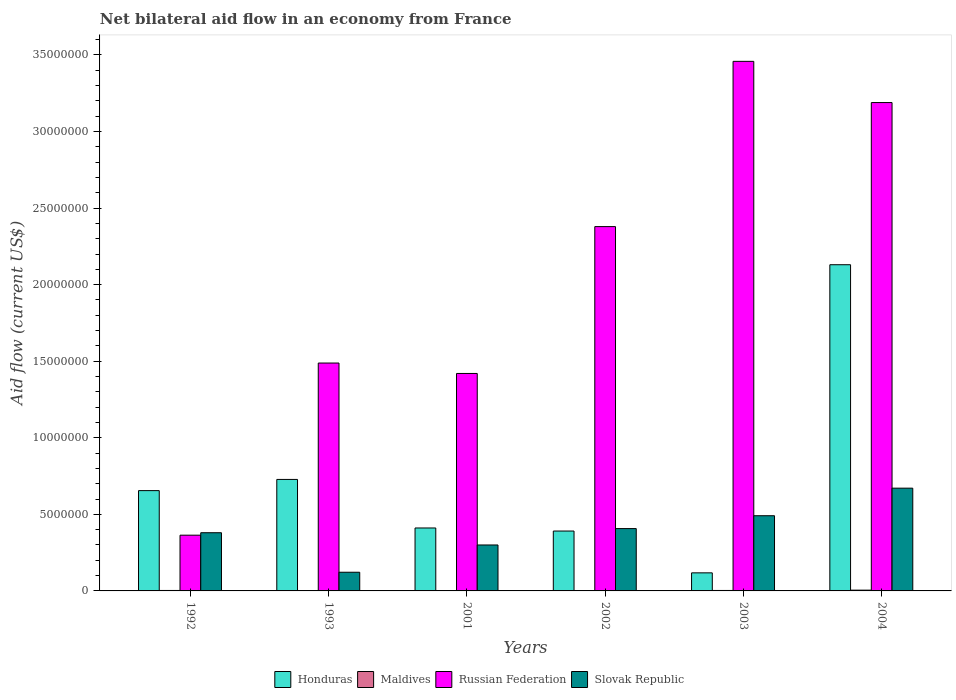How many bars are there on the 2nd tick from the left?
Provide a succinct answer. 4. In how many cases, is the number of bars for a given year not equal to the number of legend labels?
Your answer should be compact. 0. What is the net bilateral aid flow in Russian Federation in 2004?
Your answer should be compact. 3.19e+07. Across all years, what is the maximum net bilateral aid flow in Honduras?
Provide a succinct answer. 2.13e+07. Across all years, what is the minimum net bilateral aid flow in Slovak Republic?
Keep it short and to the point. 1.22e+06. In which year was the net bilateral aid flow in Maldives minimum?
Make the answer very short. 1993. What is the total net bilateral aid flow in Russian Federation in the graph?
Make the answer very short. 1.23e+08. What is the difference between the net bilateral aid flow in Russian Federation in 1993 and that in 2002?
Offer a terse response. -8.91e+06. What is the difference between the net bilateral aid flow in Slovak Republic in 1992 and the net bilateral aid flow in Honduras in 2004?
Your response must be concise. -1.75e+07. What is the average net bilateral aid flow in Slovak Republic per year?
Provide a short and direct response. 3.95e+06. In the year 2004, what is the difference between the net bilateral aid flow in Russian Federation and net bilateral aid flow in Honduras?
Provide a short and direct response. 1.06e+07. What is the ratio of the net bilateral aid flow in Slovak Republic in 2001 to that in 2003?
Provide a short and direct response. 0.61. Is the net bilateral aid flow in Maldives in 2001 less than that in 2004?
Your answer should be compact. Yes. What is the difference between the highest and the second highest net bilateral aid flow in Maldives?
Your answer should be compact. 2.00e+04. What is the difference between the highest and the lowest net bilateral aid flow in Honduras?
Your answer should be very brief. 2.01e+07. Is the sum of the net bilateral aid flow in Honduras in 1993 and 2002 greater than the maximum net bilateral aid flow in Maldives across all years?
Your answer should be compact. Yes. What does the 1st bar from the left in 2004 represents?
Keep it short and to the point. Honduras. What does the 1st bar from the right in 1992 represents?
Offer a terse response. Slovak Republic. Is it the case that in every year, the sum of the net bilateral aid flow in Honduras and net bilateral aid flow in Russian Federation is greater than the net bilateral aid flow in Maldives?
Provide a short and direct response. Yes. How many bars are there?
Ensure brevity in your answer.  24. What is the difference between two consecutive major ticks on the Y-axis?
Your response must be concise. 5.00e+06. Are the values on the major ticks of Y-axis written in scientific E-notation?
Offer a terse response. No. Does the graph contain any zero values?
Offer a very short reply. No. Does the graph contain grids?
Keep it short and to the point. No. Where does the legend appear in the graph?
Your answer should be compact. Bottom center. How many legend labels are there?
Offer a very short reply. 4. What is the title of the graph?
Provide a succinct answer. Net bilateral aid flow in an economy from France. What is the Aid flow (current US$) in Honduras in 1992?
Offer a very short reply. 6.55e+06. What is the Aid flow (current US$) in Maldives in 1992?
Your answer should be compact. 3.00e+04. What is the Aid flow (current US$) in Russian Federation in 1992?
Give a very brief answer. 3.64e+06. What is the Aid flow (current US$) in Slovak Republic in 1992?
Ensure brevity in your answer.  3.80e+06. What is the Aid flow (current US$) of Honduras in 1993?
Ensure brevity in your answer.  7.28e+06. What is the Aid flow (current US$) of Russian Federation in 1993?
Offer a terse response. 1.49e+07. What is the Aid flow (current US$) of Slovak Republic in 1993?
Offer a terse response. 1.22e+06. What is the Aid flow (current US$) in Honduras in 2001?
Offer a very short reply. 4.11e+06. What is the Aid flow (current US$) of Russian Federation in 2001?
Offer a very short reply. 1.42e+07. What is the Aid flow (current US$) in Honduras in 2002?
Your answer should be very brief. 3.91e+06. What is the Aid flow (current US$) of Maldives in 2002?
Keep it short and to the point. 2.00e+04. What is the Aid flow (current US$) of Russian Federation in 2002?
Your response must be concise. 2.38e+07. What is the Aid flow (current US$) of Slovak Republic in 2002?
Offer a very short reply. 4.07e+06. What is the Aid flow (current US$) of Honduras in 2003?
Make the answer very short. 1.18e+06. What is the Aid flow (current US$) in Russian Federation in 2003?
Offer a terse response. 3.46e+07. What is the Aid flow (current US$) in Slovak Republic in 2003?
Provide a succinct answer. 4.91e+06. What is the Aid flow (current US$) of Honduras in 2004?
Your answer should be very brief. 2.13e+07. What is the Aid flow (current US$) of Maldives in 2004?
Provide a succinct answer. 5.00e+04. What is the Aid flow (current US$) of Russian Federation in 2004?
Offer a terse response. 3.19e+07. What is the Aid flow (current US$) of Slovak Republic in 2004?
Provide a short and direct response. 6.71e+06. Across all years, what is the maximum Aid flow (current US$) in Honduras?
Offer a very short reply. 2.13e+07. Across all years, what is the maximum Aid flow (current US$) in Russian Federation?
Make the answer very short. 3.46e+07. Across all years, what is the maximum Aid flow (current US$) of Slovak Republic?
Keep it short and to the point. 6.71e+06. Across all years, what is the minimum Aid flow (current US$) in Honduras?
Make the answer very short. 1.18e+06. Across all years, what is the minimum Aid flow (current US$) of Russian Federation?
Your response must be concise. 3.64e+06. Across all years, what is the minimum Aid flow (current US$) in Slovak Republic?
Your answer should be compact. 1.22e+06. What is the total Aid flow (current US$) in Honduras in the graph?
Your answer should be very brief. 4.43e+07. What is the total Aid flow (current US$) in Maldives in the graph?
Provide a succinct answer. 1.60e+05. What is the total Aid flow (current US$) of Russian Federation in the graph?
Your answer should be compact. 1.23e+08. What is the total Aid flow (current US$) in Slovak Republic in the graph?
Provide a short and direct response. 2.37e+07. What is the difference between the Aid flow (current US$) in Honduras in 1992 and that in 1993?
Ensure brevity in your answer.  -7.30e+05. What is the difference between the Aid flow (current US$) of Maldives in 1992 and that in 1993?
Offer a very short reply. 2.00e+04. What is the difference between the Aid flow (current US$) of Russian Federation in 1992 and that in 1993?
Provide a short and direct response. -1.12e+07. What is the difference between the Aid flow (current US$) of Slovak Republic in 1992 and that in 1993?
Give a very brief answer. 2.58e+06. What is the difference between the Aid flow (current US$) in Honduras in 1992 and that in 2001?
Provide a succinct answer. 2.44e+06. What is the difference between the Aid flow (current US$) of Maldives in 1992 and that in 2001?
Make the answer very short. 10000. What is the difference between the Aid flow (current US$) in Russian Federation in 1992 and that in 2001?
Make the answer very short. -1.06e+07. What is the difference between the Aid flow (current US$) of Honduras in 1992 and that in 2002?
Your answer should be very brief. 2.64e+06. What is the difference between the Aid flow (current US$) in Russian Federation in 1992 and that in 2002?
Your answer should be very brief. -2.02e+07. What is the difference between the Aid flow (current US$) in Slovak Republic in 1992 and that in 2002?
Your answer should be compact. -2.70e+05. What is the difference between the Aid flow (current US$) in Honduras in 1992 and that in 2003?
Your response must be concise. 5.37e+06. What is the difference between the Aid flow (current US$) in Russian Federation in 1992 and that in 2003?
Ensure brevity in your answer.  -3.09e+07. What is the difference between the Aid flow (current US$) in Slovak Republic in 1992 and that in 2003?
Offer a very short reply. -1.11e+06. What is the difference between the Aid flow (current US$) of Honduras in 1992 and that in 2004?
Your answer should be very brief. -1.48e+07. What is the difference between the Aid flow (current US$) in Maldives in 1992 and that in 2004?
Keep it short and to the point. -2.00e+04. What is the difference between the Aid flow (current US$) in Russian Federation in 1992 and that in 2004?
Keep it short and to the point. -2.82e+07. What is the difference between the Aid flow (current US$) of Slovak Republic in 1992 and that in 2004?
Your answer should be very brief. -2.91e+06. What is the difference between the Aid flow (current US$) in Honduras in 1993 and that in 2001?
Provide a succinct answer. 3.17e+06. What is the difference between the Aid flow (current US$) of Russian Federation in 1993 and that in 2001?
Provide a succinct answer. 6.80e+05. What is the difference between the Aid flow (current US$) in Slovak Republic in 1993 and that in 2001?
Keep it short and to the point. -1.78e+06. What is the difference between the Aid flow (current US$) of Honduras in 1993 and that in 2002?
Your answer should be very brief. 3.37e+06. What is the difference between the Aid flow (current US$) in Maldives in 1993 and that in 2002?
Give a very brief answer. -10000. What is the difference between the Aid flow (current US$) of Russian Federation in 1993 and that in 2002?
Your response must be concise. -8.91e+06. What is the difference between the Aid flow (current US$) in Slovak Republic in 1993 and that in 2002?
Provide a short and direct response. -2.85e+06. What is the difference between the Aid flow (current US$) of Honduras in 1993 and that in 2003?
Your answer should be very brief. 6.10e+06. What is the difference between the Aid flow (current US$) of Russian Federation in 1993 and that in 2003?
Provide a succinct answer. -1.97e+07. What is the difference between the Aid flow (current US$) in Slovak Republic in 1993 and that in 2003?
Give a very brief answer. -3.69e+06. What is the difference between the Aid flow (current US$) in Honduras in 1993 and that in 2004?
Ensure brevity in your answer.  -1.40e+07. What is the difference between the Aid flow (current US$) in Maldives in 1993 and that in 2004?
Your answer should be very brief. -4.00e+04. What is the difference between the Aid flow (current US$) in Russian Federation in 1993 and that in 2004?
Provide a short and direct response. -1.70e+07. What is the difference between the Aid flow (current US$) of Slovak Republic in 1993 and that in 2004?
Provide a succinct answer. -5.49e+06. What is the difference between the Aid flow (current US$) in Maldives in 2001 and that in 2002?
Your answer should be compact. 0. What is the difference between the Aid flow (current US$) in Russian Federation in 2001 and that in 2002?
Provide a short and direct response. -9.59e+06. What is the difference between the Aid flow (current US$) in Slovak Republic in 2001 and that in 2002?
Your answer should be very brief. -1.07e+06. What is the difference between the Aid flow (current US$) of Honduras in 2001 and that in 2003?
Make the answer very short. 2.93e+06. What is the difference between the Aid flow (current US$) of Maldives in 2001 and that in 2003?
Your response must be concise. -10000. What is the difference between the Aid flow (current US$) in Russian Federation in 2001 and that in 2003?
Give a very brief answer. -2.04e+07. What is the difference between the Aid flow (current US$) in Slovak Republic in 2001 and that in 2003?
Your answer should be very brief. -1.91e+06. What is the difference between the Aid flow (current US$) of Honduras in 2001 and that in 2004?
Provide a succinct answer. -1.72e+07. What is the difference between the Aid flow (current US$) of Maldives in 2001 and that in 2004?
Keep it short and to the point. -3.00e+04. What is the difference between the Aid flow (current US$) in Russian Federation in 2001 and that in 2004?
Your answer should be very brief. -1.77e+07. What is the difference between the Aid flow (current US$) in Slovak Republic in 2001 and that in 2004?
Offer a terse response. -3.71e+06. What is the difference between the Aid flow (current US$) in Honduras in 2002 and that in 2003?
Provide a short and direct response. 2.73e+06. What is the difference between the Aid flow (current US$) in Russian Federation in 2002 and that in 2003?
Offer a very short reply. -1.08e+07. What is the difference between the Aid flow (current US$) in Slovak Republic in 2002 and that in 2003?
Your answer should be compact. -8.40e+05. What is the difference between the Aid flow (current US$) of Honduras in 2002 and that in 2004?
Your answer should be very brief. -1.74e+07. What is the difference between the Aid flow (current US$) in Maldives in 2002 and that in 2004?
Ensure brevity in your answer.  -3.00e+04. What is the difference between the Aid flow (current US$) of Russian Federation in 2002 and that in 2004?
Your response must be concise. -8.10e+06. What is the difference between the Aid flow (current US$) of Slovak Republic in 2002 and that in 2004?
Offer a terse response. -2.64e+06. What is the difference between the Aid flow (current US$) in Honduras in 2003 and that in 2004?
Give a very brief answer. -2.01e+07. What is the difference between the Aid flow (current US$) in Maldives in 2003 and that in 2004?
Make the answer very short. -2.00e+04. What is the difference between the Aid flow (current US$) in Russian Federation in 2003 and that in 2004?
Your answer should be compact. 2.69e+06. What is the difference between the Aid flow (current US$) of Slovak Republic in 2003 and that in 2004?
Your answer should be compact. -1.80e+06. What is the difference between the Aid flow (current US$) of Honduras in 1992 and the Aid flow (current US$) of Maldives in 1993?
Keep it short and to the point. 6.54e+06. What is the difference between the Aid flow (current US$) in Honduras in 1992 and the Aid flow (current US$) in Russian Federation in 1993?
Ensure brevity in your answer.  -8.33e+06. What is the difference between the Aid flow (current US$) of Honduras in 1992 and the Aid flow (current US$) of Slovak Republic in 1993?
Provide a succinct answer. 5.33e+06. What is the difference between the Aid flow (current US$) of Maldives in 1992 and the Aid flow (current US$) of Russian Federation in 1993?
Ensure brevity in your answer.  -1.48e+07. What is the difference between the Aid flow (current US$) of Maldives in 1992 and the Aid flow (current US$) of Slovak Republic in 1993?
Your response must be concise. -1.19e+06. What is the difference between the Aid flow (current US$) of Russian Federation in 1992 and the Aid flow (current US$) of Slovak Republic in 1993?
Make the answer very short. 2.42e+06. What is the difference between the Aid flow (current US$) of Honduras in 1992 and the Aid flow (current US$) of Maldives in 2001?
Make the answer very short. 6.53e+06. What is the difference between the Aid flow (current US$) in Honduras in 1992 and the Aid flow (current US$) in Russian Federation in 2001?
Your response must be concise. -7.65e+06. What is the difference between the Aid flow (current US$) in Honduras in 1992 and the Aid flow (current US$) in Slovak Republic in 2001?
Keep it short and to the point. 3.55e+06. What is the difference between the Aid flow (current US$) in Maldives in 1992 and the Aid flow (current US$) in Russian Federation in 2001?
Keep it short and to the point. -1.42e+07. What is the difference between the Aid flow (current US$) in Maldives in 1992 and the Aid flow (current US$) in Slovak Republic in 2001?
Keep it short and to the point. -2.97e+06. What is the difference between the Aid flow (current US$) of Russian Federation in 1992 and the Aid flow (current US$) of Slovak Republic in 2001?
Offer a very short reply. 6.40e+05. What is the difference between the Aid flow (current US$) of Honduras in 1992 and the Aid flow (current US$) of Maldives in 2002?
Your answer should be compact. 6.53e+06. What is the difference between the Aid flow (current US$) in Honduras in 1992 and the Aid flow (current US$) in Russian Federation in 2002?
Ensure brevity in your answer.  -1.72e+07. What is the difference between the Aid flow (current US$) of Honduras in 1992 and the Aid flow (current US$) of Slovak Republic in 2002?
Give a very brief answer. 2.48e+06. What is the difference between the Aid flow (current US$) of Maldives in 1992 and the Aid flow (current US$) of Russian Federation in 2002?
Ensure brevity in your answer.  -2.38e+07. What is the difference between the Aid flow (current US$) of Maldives in 1992 and the Aid flow (current US$) of Slovak Republic in 2002?
Ensure brevity in your answer.  -4.04e+06. What is the difference between the Aid flow (current US$) of Russian Federation in 1992 and the Aid flow (current US$) of Slovak Republic in 2002?
Offer a very short reply. -4.30e+05. What is the difference between the Aid flow (current US$) in Honduras in 1992 and the Aid flow (current US$) in Maldives in 2003?
Your answer should be compact. 6.52e+06. What is the difference between the Aid flow (current US$) in Honduras in 1992 and the Aid flow (current US$) in Russian Federation in 2003?
Your answer should be very brief. -2.80e+07. What is the difference between the Aid flow (current US$) of Honduras in 1992 and the Aid flow (current US$) of Slovak Republic in 2003?
Offer a very short reply. 1.64e+06. What is the difference between the Aid flow (current US$) in Maldives in 1992 and the Aid flow (current US$) in Russian Federation in 2003?
Ensure brevity in your answer.  -3.46e+07. What is the difference between the Aid flow (current US$) in Maldives in 1992 and the Aid flow (current US$) in Slovak Republic in 2003?
Offer a terse response. -4.88e+06. What is the difference between the Aid flow (current US$) of Russian Federation in 1992 and the Aid flow (current US$) of Slovak Republic in 2003?
Your answer should be very brief. -1.27e+06. What is the difference between the Aid flow (current US$) in Honduras in 1992 and the Aid flow (current US$) in Maldives in 2004?
Offer a terse response. 6.50e+06. What is the difference between the Aid flow (current US$) of Honduras in 1992 and the Aid flow (current US$) of Russian Federation in 2004?
Offer a very short reply. -2.53e+07. What is the difference between the Aid flow (current US$) in Honduras in 1992 and the Aid flow (current US$) in Slovak Republic in 2004?
Offer a terse response. -1.60e+05. What is the difference between the Aid flow (current US$) of Maldives in 1992 and the Aid flow (current US$) of Russian Federation in 2004?
Your answer should be very brief. -3.19e+07. What is the difference between the Aid flow (current US$) in Maldives in 1992 and the Aid flow (current US$) in Slovak Republic in 2004?
Your answer should be very brief. -6.68e+06. What is the difference between the Aid flow (current US$) of Russian Federation in 1992 and the Aid flow (current US$) of Slovak Republic in 2004?
Provide a succinct answer. -3.07e+06. What is the difference between the Aid flow (current US$) in Honduras in 1993 and the Aid flow (current US$) in Maldives in 2001?
Give a very brief answer. 7.26e+06. What is the difference between the Aid flow (current US$) of Honduras in 1993 and the Aid flow (current US$) of Russian Federation in 2001?
Your answer should be very brief. -6.92e+06. What is the difference between the Aid flow (current US$) of Honduras in 1993 and the Aid flow (current US$) of Slovak Republic in 2001?
Your answer should be compact. 4.28e+06. What is the difference between the Aid flow (current US$) of Maldives in 1993 and the Aid flow (current US$) of Russian Federation in 2001?
Give a very brief answer. -1.42e+07. What is the difference between the Aid flow (current US$) in Maldives in 1993 and the Aid flow (current US$) in Slovak Republic in 2001?
Your response must be concise. -2.99e+06. What is the difference between the Aid flow (current US$) in Russian Federation in 1993 and the Aid flow (current US$) in Slovak Republic in 2001?
Make the answer very short. 1.19e+07. What is the difference between the Aid flow (current US$) of Honduras in 1993 and the Aid flow (current US$) of Maldives in 2002?
Your answer should be compact. 7.26e+06. What is the difference between the Aid flow (current US$) of Honduras in 1993 and the Aid flow (current US$) of Russian Federation in 2002?
Your response must be concise. -1.65e+07. What is the difference between the Aid flow (current US$) of Honduras in 1993 and the Aid flow (current US$) of Slovak Republic in 2002?
Your answer should be very brief. 3.21e+06. What is the difference between the Aid flow (current US$) of Maldives in 1993 and the Aid flow (current US$) of Russian Federation in 2002?
Offer a terse response. -2.38e+07. What is the difference between the Aid flow (current US$) of Maldives in 1993 and the Aid flow (current US$) of Slovak Republic in 2002?
Offer a very short reply. -4.06e+06. What is the difference between the Aid flow (current US$) in Russian Federation in 1993 and the Aid flow (current US$) in Slovak Republic in 2002?
Your response must be concise. 1.08e+07. What is the difference between the Aid flow (current US$) in Honduras in 1993 and the Aid flow (current US$) in Maldives in 2003?
Your answer should be very brief. 7.25e+06. What is the difference between the Aid flow (current US$) of Honduras in 1993 and the Aid flow (current US$) of Russian Federation in 2003?
Provide a short and direct response. -2.73e+07. What is the difference between the Aid flow (current US$) of Honduras in 1993 and the Aid flow (current US$) of Slovak Republic in 2003?
Offer a terse response. 2.37e+06. What is the difference between the Aid flow (current US$) of Maldives in 1993 and the Aid flow (current US$) of Russian Federation in 2003?
Give a very brief answer. -3.46e+07. What is the difference between the Aid flow (current US$) of Maldives in 1993 and the Aid flow (current US$) of Slovak Republic in 2003?
Provide a succinct answer. -4.90e+06. What is the difference between the Aid flow (current US$) in Russian Federation in 1993 and the Aid flow (current US$) in Slovak Republic in 2003?
Offer a terse response. 9.97e+06. What is the difference between the Aid flow (current US$) in Honduras in 1993 and the Aid flow (current US$) in Maldives in 2004?
Ensure brevity in your answer.  7.23e+06. What is the difference between the Aid flow (current US$) in Honduras in 1993 and the Aid flow (current US$) in Russian Federation in 2004?
Offer a very short reply. -2.46e+07. What is the difference between the Aid flow (current US$) of Honduras in 1993 and the Aid flow (current US$) of Slovak Republic in 2004?
Your answer should be compact. 5.70e+05. What is the difference between the Aid flow (current US$) in Maldives in 1993 and the Aid flow (current US$) in Russian Federation in 2004?
Give a very brief answer. -3.19e+07. What is the difference between the Aid flow (current US$) of Maldives in 1993 and the Aid flow (current US$) of Slovak Republic in 2004?
Offer a terse response. -6.70e+06. What is the difference between the Aid flow (current US$) in Russian Federation in 1993 and the Aid flow (current US$) in Slovak Republic in 2004?
Make the answer very short. 8.17e+06. What is the difference between the Aid flow (current US$) in Honduras in 2001 and the Aid flow (current US$) in Maldives in 2002?
Your answer should be very brief. 4.09e+06. What is the difference between the Aid flow (current US$) in Honduras in 2001 and the Aid flow (current US$) in Russian Federation in 2002?
Your response must be concise. -1.97e+07. What is the difference between the Aid flow (current US$) in Maldives in 2001 and the Aid flow (current US$) in Russian Federation in 2002?
Your response must be concise. -2.38e+07. What is the difference between the Aid flow (current US$) in Maldives in 2001 and the Aid flow (current US$) in Slovak Republic in 2002?
Make the answer very short. -4.05e+06. What is the difference between the Aid flow (current US$) in Russian Federation in 2001 and the Aid flow (current US$) in Slovak Republic in 2002?
Make the answer very short. 1.01e+07. What is the difference between the Aid flow (current US$) in Honduras in 2001 and the Aid flow (current US$) in Maldives in 2003?
Provide a short and direct response. 4.08e+06. What is the difference between the Aid flow (current US$) of Honduras in 2001 and the Aid flow (current US$) of Russian Federation in 2003?
Provide a short and direct response. -3.05e+07. What is the difference between the Aid flow (current US$) of Honduras in 2001 and the Aid flow (current US$) of Slovak Republic in 2003?
Offer a terse response. -8.00e+05. What is the difference between the Aid flow (current US$) of Maldives in 2001 and the Aid flow (current US$) of Russian Federation in 2003?
Make the answer very short. -3.46e+07. What is the difference between the Aid flow (current US$) of Maldives in 2001 and the Aid flow (current US$) of Slovak Republic in 2003?
Ensure brevity in your answer.  -4.89e+06. What is the difference between the Aid flow (current US$) of Russian Federation in 2001 and the Aid flow (current US$) of Slovak Republic in 2003?
Give a very brief answer. 9.29e+06. What is the difference between the Aid flow (current US$) in Honduras in 2001 and the Aid flow (current US$) in Maldives in 2004?
Offer a very short reply. 4.06e+06. What is the difference between the Aid flow (current US$) of Honduras in 2001 and the Aid flow (current US$) of Russian Federation in 2004?
Provide a succinct answer. -2.78e+07. What is the difference between the Aid flow (current US$) of Honduras in 2001 and the Aid flow (current US$) of Slovak Republic in 2004?
Ensure brevity in your answer.  -2.60e+06. What is the difference between the Aid flow (current US$) of Maldives in 2001 and the Aid flow (current US$) of Russian Federation in 2004?
Keep it short and to the point. -3.19e+07. What is the difference between the Aid flow (current US$) of Maldives in 2001 and the Aid flow (current US$) of Slovak Republic in 2004?
Offer a very short reply. -6.69e+06. What is the difference between the Aid flow (current US$) in Russian Federation in 2001 and the Aid flow (current US$) in Slovak Republic in 2004?
Provide a short and direct response. 7.49e+06. What is the difference between the Aid flow (current US$) in Honduras in 2002 and the Aid flow (current US$) in Maldives in 2003?
Offer a very short reply. 3.88e+06. What is the difference between the Aid flow (current US$) in Honduras in 2002 and the Aid flow (current US$) in Russian Federation in 2003?
Make the answer very short. -3.07e+07. What is the difference between the Aid flow (current US$) in Honduras in 2002 and the Aid flow (current US$) in Slovak Republic in 2003?
Give a very brief answer. -1.00e+06. What is the difference between the Aid flow (current US$) of Maldives in 2002 and the Aid flow (current US$) of Russian Federation in 2003?
Ensure brevity in your answer.  -3.46e+07. What is the difference between the Aid flow (current US$) in Maldives in 2002 and the Aid flow (current US$) in Slovak Republic in 2003?
Provide a succinct answer. -4.89e+06. What is the difference between the Aid flow (current US$) in Russian Federation in 2002 and the Aid flow (current US$) in Slovak Republic in 2003?
Your answer should be compact. 1.89e+07. What is the difference between the Aid flow (current US$) of Honduras in 2002 and the Aid flow (current US$) of Maldives in 2004?
Keep it short and to the point. 3.86e+06. What is the difference between the Aid flow (current US$) in Honduras in 2002 and the Aid flow (current US$) in Russian Federation in 2004?
Your answer should be compact. -2.80e+07. What is the difference between the Aid flow (current US$) in Honduras in 2002 and the Aid flow (current US$) in Slovak Republic in 2004?
Give a very brief answer. -2.80e+06. What is the difference between the Aid flow (current US$) in Maldives in 2002 and the Aid flow (current US$) in Russian Federation in 2004?
Give a very brief answer. -3.19e+07. What is the difference between the Aid flow (current US$) of Maldives in 2002 and the Aid flow (current US$) of Slovak Republic in 2004?
Your response must be concise. -6.69e+06. What is the difference between the Aid flow (current US$) in Russian Federation in 2002 and the Aid flow (current US$) in Slovak Republic in 2004?
Offer a terse response. 1.71e+07. What is the difference between the Aid flow (current US$) of Honduras in 2003 and the Aid flow (current US$) of Maldives in 2004?
Give a very brief answer. 1.13e+06. What is the difference between the Aid flow (current US$) in Honduras in 2003 and the Aid flow (current US$) in Russian Federation in 2004?
Ensure brevity in your answer.  -3.07e+07. What is the difference between the Aid flow (current US$) of Honduras in 2003 and the Aid flow (current US$) of Slovak Republic in 2004?
Your response must be concise. -5.53e+06. What is the difference between the Aid flow (current US$) in Maldives in 2003 and the Aid flow (current US$) in Russian Federation in 2004?
Keep it short and to the point. -3.19e+07. What is the difference between the Aid flow (current US$) of Maldives in 2003 and the Aid flow (current US$) of Slovak Republic in 2004?
Provide a succinct answer. -6.68e+06. What is the difference between the Aid flow (current US$) of Russian Federation in 2003 and the Aid flow (current US$) of Slovak Republic in 2004?
Provide a short and direct response. 2.79e+07. What is the average Aid flow (current US$) in Honduras per year?
Keep it short and to the point. 7.39e+06. What is the average Aid flow (current US$) in Maldives per year?
Provide a succinct answer. 2.67e+04. What is the average Aid flow (current US$) in Russian Federation per year?
Keep it short and to the point. 2.05e+07. What is the average Aid flow (current US$) of Slovak Republic per year?
Give a very brief answer. 3.95e+06. In the year 1992, what is the difference between the Aid flow (current US$) of Honduras and Aid flow (current US$) of Maldives?
Your answer should be very brief. 6.52e+06. In the year 1992, what is the difference between the Aid flow (current US$) of Honduras and Aid flow (current US$) of Russian Federation?
Ensure brevity in your answer.  2.91e+06. In the year 1992, what is the difference between the Aid flow (current US$) of Honduras and Aid flow (current US$) of Slovak Republic?
Keep it short and to the point. 2.75e+06. In the year 1992, what is the difference between the Aid flow (current US$) of Maldives and Aid flow (current US$) of Russian Federation?
Provide a short and direct response. -3.61e+06. In the year 1992, what is the difference between the Aid flow (current US$) in Maldives and Aid flow (current US$) in Slovak Republic?
Your answer should be very brief. -3.77e+06. In the year 1992, what is the difference between the Aid flow (current US$) in Russian Federation and Aid flow (current US$) in Slovak Republic?
Ensure brevity in your answer.  -1.60e+05. In the year 1993, what is the difference between the Aid flow (current US$) in Honduras and Aid flow (current US$) in Maldives?
Ensure brevity in your answer.  7.27e+06. In the year 1993, what is the difference between the Aid flow (current US$) in Honduras and Aid flow (current US$) in Russian Federation?
Your response must be concise. -7.60e+06. In the year 1993, what is the difference between the Aid flow (current US$) of Honduras and Aid flow (current US$) of Slovak Republic?
Ensure brevity in your answer.  6.06e+06. In the year 1993, what is the difference between the Aid flow (current US$) in Maldives and Aid flow (current US$) in Russian Federation?
Give a very brief answer. -1.49e+07. In the year 1993, what is the difference between the Aid flow (current US$) of Maldives and Aid flow (current US$) of Slovak Republic?
Keep it short and to the point. -1.21e+06. In the year 1993, what is the difference between the Aid flow (current US$) of Russian Federation and Aid flow (current US$) of Slovak Republic?
Ensure brevity in your answer.  1.37e+07. In the year 2001, what is the difference between the Aid flow (current US$) of Honduras and Aid flow (current US$) of Maldives?
Ensure brevity in your answer.  4.09e+06. In the year 2001, what is the difference between the Aid flow (current US$) in Honduras and Aid flow (current US$) in Russian Federation?
Make the answer very short. -1.01e+07. In the year 2001, what is the difference between the Aid flow (current US$) of Honduras and Aid flow (current US$) of Slovak Republic?
Make the answer very short. 1.11e+06. In the year 2001, what is the difference between the Aid flow (current US$) in Maldives and Aid flow (current US$) in Russian Federation?
Ensure brevity in your answer.  -1.42e+07. In the year 2001, what is the difference between the Aid flow (current US$) of Maldives and Aid flow (current US$) of Slovak Republic?
Give a very brief answer. -2.98e+06. In the year 2001, what is the difference between the Aid flow (current US$) in Russian Federation and Aid flow (current US$) in Slovak Republic?
Provide a short and direct response. 1.12e+07. In the year 2002, what is the difference between the Aid flow (current US$) in Honduras and Aid flow (current US$) in Maldives?
Ensure brevity in your answer.  3.89e+06. In the year 2002, what is the difference between the Aid flow (current US$) of Honduras and Aid flow (current US$) of Russian Federation?
Give a very brief answer. -1.99e+07. In the year 2002, what is the difference between the Aid flow (current US$) of Honduras and Aid flow (current US$) of Slovak Republic?
Give a very brief answer. -1.60e+05. In the year 2002, what is the difference between the Aid flow (current US$) in Maldives and Aid flow (current US$) in Russian Federation?
Your answer should be compact. -2.38e+07. In the year 2002, what is the difference between the Aid flow (current US$) of Maldives and Aid flow (current US$) of Slovak Republic?
Keep it short and to the point. -4.05e+06. In the year 2002, what is the difference between the Aid flow (current US$) of Russian Federation and Aid flow (current US$) of Slovak Republic?
Give a very brief answer. 1.97e+07. In the year 2003, what is the difference between the Aid flow (current US$) in Honduras and Aid flow (current US$) in Maldives?
Offer a terse response. 1.15e+06. In the year 2003, what is the difference between the Aid flow (current US$) in Honduras and Aid flow (current US$) in Russian Federation?
Your answer should be compact. -3.34e+07. In the year 2003, what is the difference between the Aid flow (current US$) of Honduras and Aid flow (current US$) of Slovak Republic?
Offer a terse response. -3.73e+06. In the year 2003, what is the difference between the Aid flow (current US$) in Maldives and Aid flow (current US$) in Russian Federation?
Ensure brevity in your answer.  -3.46e+07. In the year 2003, what is the difference between the Aid flow (current US$) of Maldives and Aid flow (current US$) of Slovak Republic?
Offer a very short reply. -4.88e+06. In the year 2003, what is the difference between the Aid flow (current US$) in Russian Federation and Aid flow (current US$) in Slovak Republic?
Your response must be concise. 2.97e+07. In the year 2004, what is the difference between the Aid flow (current US$) in Honduras and Aid flow (current US$) in Maldives?
Make the answer very short. 2.12e+07. In the year 2004, what is the difference between the Aid flow (current US$) in Honduras and Aid flow (current US$) in Russian Federation?
Your answer should be compact. -1.06e+07. In the year 2004, what is the difference between the Aid flow (current US$) of Honduras and Aid flow (current US$) of Slovak Republic?
Ensure brevity in your answer.  1.46e+07. In the year 2004, what is the difference between the Aid flow (current US$) in Maldives and Aid flow (current US$) in Russian Federation?
Make the answer very short. -3.18e+07. In the year 2004, what is the difference between the Aid flow (current US$) in Maldives and Aid flow (current US$) in Slovak Republic?
Give a very brief answer. -6.66e+06. In the year 2004, what is the difference between the Aid flow (current US$) in Russian Federation and Aid flow (current US$) in Slovak Republic?
Provide a succinct answer. 2.52e+07. What is the ratio of the Aid flow (current US$) of Honduras in 1992 to that in 1993?
Your answer should be very brief. 0.9. What is the ratio of the Aid flow (current US$) of Maldives in 1992 to that in 1993?
Your answer should be compact. 3. What is the ratio of the Aid flow (current US$) in Russian Federation in 1992 to that in 1993?
Offer a very short reply. 0.24. What is the ratio of the Aid flow (current US$) in Slovak Republic in 1992 to that in 1993?
Offer a very short reply. 3.11. What is the ratio of the Aid flow (current US$) in Honduras in 1992 to that in 2001?
Your response must be concise. 1.59. What is the ratio of the Aid flow (current US$) of Russian Federation in 1992 to that in 2001?
Ensure brevity in your answer.  0.26. What is the ratio of the Aid flow (current US$) in Slovak Republic in 1992 to that in 2001?
Keep it short and to the point. 1.27. What is the ratio of the Aid flow (current US$) of Honduras in 1992 to that in 2002?
Your answer should be compact. 1.68. What is the ratio of the Aid flow (current US$) of Maldives in 1992 to that in 2002?
Ensure brevity in your answer.  1.5. What is the ratio of the Aid flow (current US$) of Russian Federation in 1992 to that in 2002?
Your response must be concise. 0.15. What is the ratio of the Aid flow (current US$) in Slovak Republic in 1992 to that in 2002?
Your answer should be compact. 0.93. What is the ratio of the Aid flow (current US$) of Honduras in 1992 to that in 2003?
Provide a short and direct response. 5.55. What is the ratio of the Aid flow (current US$) of Maldives in 1992 to that in 2003?
Provide a succinct answer. 1. What is the ratio of the Aid flow (current US$) of Russian Federation in 1992 to that in 2003?
Ensure brevity in your answer.  0.11. What is the ratio of the Aid flow (current US$) of Slovak Republic in 1992 to that in 2003?
Offer a terse response. 0.77. What is the ratio of the Aid flow (current US$) of Honduras in 1992 to that in 2004?
Offer a very short reply. 0.31. What is the ratio of the Aid flow (current US$) of Russian Federation in 1992 to that in 2004?
Provide a succinct answer. 0.11. What is the ratio of the Aid flow (current US$) of Slovak Republic in 1992 to that in 2004?
Your answer should be very brief. 0.57. What is the ratio of the Aid flow (current US$) in Honduras in 1993 to that in 2001?
Give a very brief answer. 1.77. What is the ratio of the Aid flow (current US$) in Russian Federation in 1993 to that in 2001?
Give a very brief answer. 1.05. What is the ratio of the Aid flow (current US$) of Slovak Republic in 1993 to that in 2001?
Your answer should be very brief. 0.41. What is the ratio of the Aid flow (current US$) of Honduras in 1993 to that in 2002?
Your answer should be compact. 1.86. What is the ratio of the Aid flow (current US$) of Russian Federation in 1993 to that in 2002?
Provide a succinct answer. 0.63. What is the ratio of the Aid flow (current US$) of Slovak Republic in 1993 to that in 2002?
Give a very brief answer. 0.3. What is the ratio of the Aid flow (current US$) of Honduras in 1993 to that in 2003?
Ensure brevity in your answer.  6.17. What is the ratio of the Aid flow (current US$) of Maldives in 1993 to that in 2003?
Ensure brevity in your answer.  0.33. What is the ratio of the Aid flow (current US$) of Russian Federation in 1993 to that in 2003?
Your response must be concise. 0.43. What is the ratio of the Aid flow (current US$) in Slovak Republic in 1993 to that in 2003?
Offer a terse response. 0.25. What is the ratio of the Aid flow (current US$) in Honduras in 1993 to that in 2004?
Provide a short and direct response. 0.34. What is the ratio of the Aid flow (current US$) of Russian Federation in 1993 to that in 2004?
Keep it short and to the point. 0.47. What is the ratio of the Aid flow (current US$) in Slovak Republic in 1993 to that in 2004?
Provide a succinct answer. 0.18. What is the ratio of the Aid flow (current US$) of Honduras in 2001 to that in 2002?
Offer a very short reply. 1.05. What is the ratio of the Aid flow (current US$) in Maldives in 2001 to that in 2002?
Ensure brevity in your answer.  1. What is the ratio of the Aid flow (current US$) in Russian Federation in 2001 to that in 2002?
Your answer should be very brief. 0.6. What is the ratio of the Aid flow (current US$) in Slovak Republic in 2001 to that in 2002?
Your answer should be very brief. 0.74. What is the ratio of the Aid flow (current US$) of Honduras in 2001 to that in 2003?
Offer a terse response. 3.48. What is the ratio of the Aid flow (current US$) of Russian Federation in 2001 to that in 2003?
Offer a terse response. 0.41. What is the ratio of the Aid flow (current US$) in Slovak Republic in 2001 to that in 2003?
Your answer should be very brief. 0.61. What is the ratio of the Aid flow (current US$) in Honduras in 2001 to that in 2004?
Offer a very short reply. 0.19. What is the ratio of the Aid flow (current US$) in Russian Federation in 2001 to that in 2004?
Make the answer very short. 0.45. What is the ratio of the Aid flow (current US$) of Slovak Republic in 2001 to that in 2004?
Make the answer very short. 0.45. What is the ratio of the Aid flow (current US$) in Honduras in 2002 to that in 2003?
Ensure brevity in your answer.  3.31. What is the ratio of the Aid flow (current US$) in Maldives in 2002 to that in 2003?
Provide a succinct answer. 0.67. What is the ratio of the Aid flow (current US$) in Russian Federation in 2002 to that in 2003?
Give a very brief answer. 0.69. What is the ratio of the Aid flow (current US$) in Slovak Republic in 2002 to that in 2003?
Keep it short and to the point. 0.83. What is the ratio of the Aid flow (current US$) of Honduras in 2002 to that in 2004?
Your response must be concise. 0.18. What is the ratio of the Aid flow (current US$) of Maldives in 2002 to that in 2004?
Provide a short and direct response. 0.4. What is the ratio of the Aid flow (current US$) in Russian Federation in 2002 to that in 2004?
Give a very brief answer. 0.75. What is the ratio of the Aid flow (current US$) in Slovak Republic in 2002 to that in 2004?
Provide a succinct answer. 0.61. What is the ratio of the Aid flow (current US$) of Honduras in 2003 to that in 2004?
Make the answer very short. 0.06. What is the ratio of the Aid flow (current US$) of Maldives in 2003 to that in 2004?
Your answer should be compact. 0.6. What is the ratio of the Aid flow (current US$) in Russian Federation in 2003 to that in 2004?
Offer a terse response. 1.08. What is the ratio of the Aid flow (current US$) of Slovak Republic in 2003 to that in 2004?
Offer a very short reply. 0.73. What is the difference between the highest and the second highest Aid flow (current US$) in Honduras?
Make the answer very short. 1.40e+07. What is the difference between the highest and the second highest Aid flow (current US$) in Russian Federation?
Ensure brevity in your answer.  2.69e+06. What is the difference between the highest and the second highest Aid flow (current US$) in Slovak Republic?
Your answer should be compact. 1.80e+06. What is the difference between the highest and the lowest Aid flow (current US$) in Honduras?
Give a very brief answer. 2.01e+07. What is the difference between the highest and the lowest Aid flow (current US$) of Maldives?
Offer a very short reply. 4.00e+04. What is the difference between the highest and the lowest Aid flow (current US$) in Russian Federation?
Provide a short and direct response. 3.09e+07. What is the difference between the highest and the lowest Aid flow (current US$) of Slovak Republic?
Your answer should be compact. 5.49e+06. 